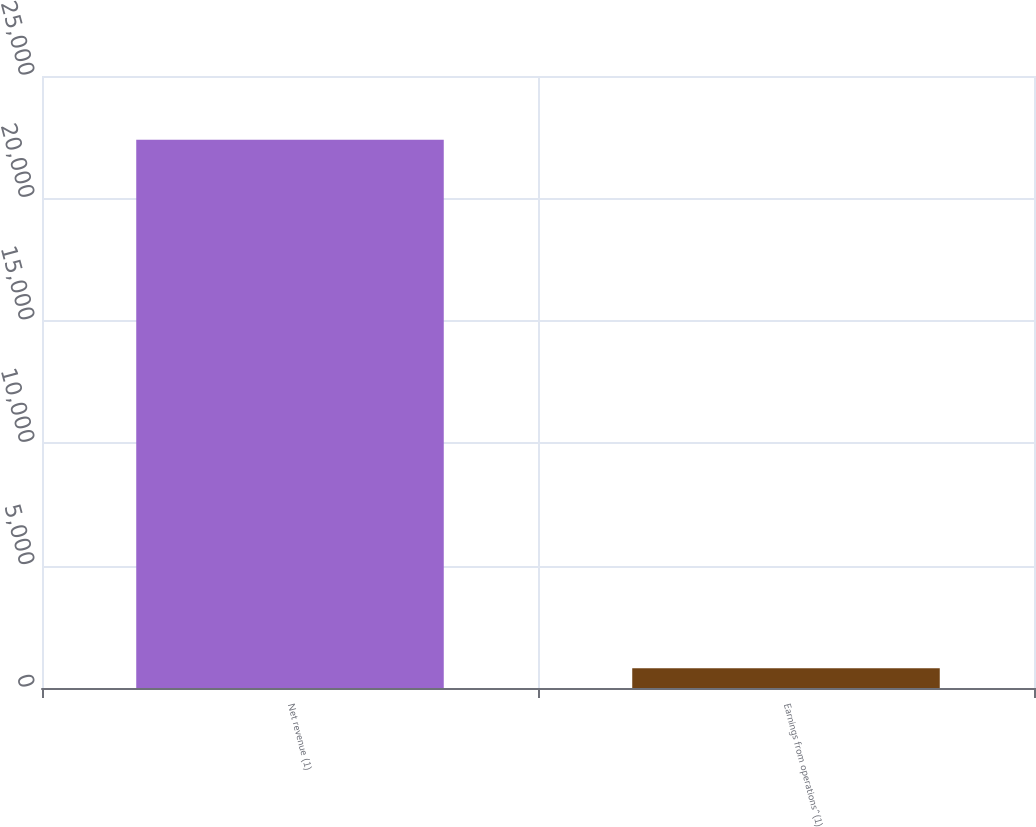<chart> <loc_0><loc_0><loc_500><loc_500><bar_chart><fcel>Net revenue (1)<fcel>Earnings from operations^(1)<nl><fcel>22398<fcel>803<nl></chart> 